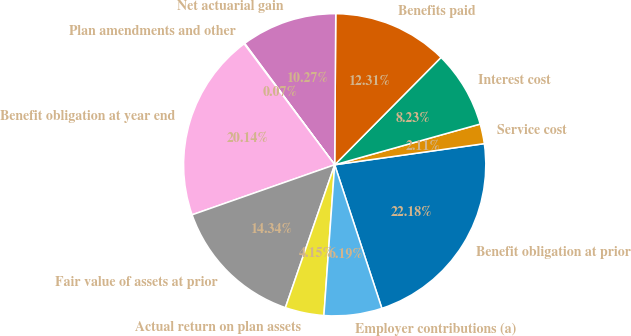<chart> <loc_0><loc_0><loc_500><loc_500><pie_chart><fcel>Benefit obligation at prior<fcel>Service cost<fcel>Interest cost<fcel>Benefits paid<fcel>Net actuarial gain<fcel>Plan amendments and other<fcel>Benefit obligation at year end<fcel>Fair value of assets at prior<fcel>Actual return on plan assets<fcel>Employer contributions (a)<nl><fcel>22.18%<fcel>2.11%<fcel>8.23%<fcel>12.31%<fcel>10.27%<fcel>0.07%<fcel>20.14%<fcel>14.34%<fcel>4.15%<fcel>6.19%<nl></chart> 